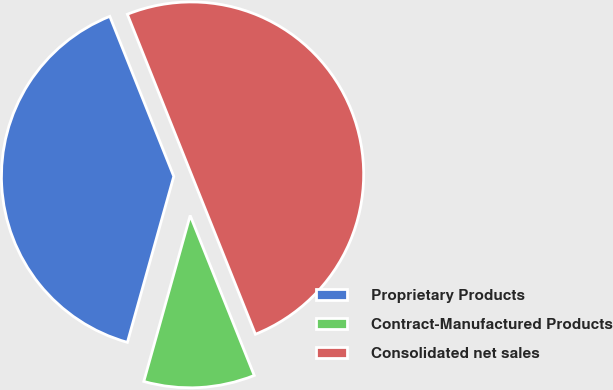Convert chart to OTSL. <chart><loc_0><loc_0><loc_500><loc_500><pie_chart><fcel>Proprietary Products<fcel>Contract-Manufactured Products<fcel>Consolidated net sales<nl><fcel>39.61%<fcel>10.4%<fcel>49.99%<nl></chart> 